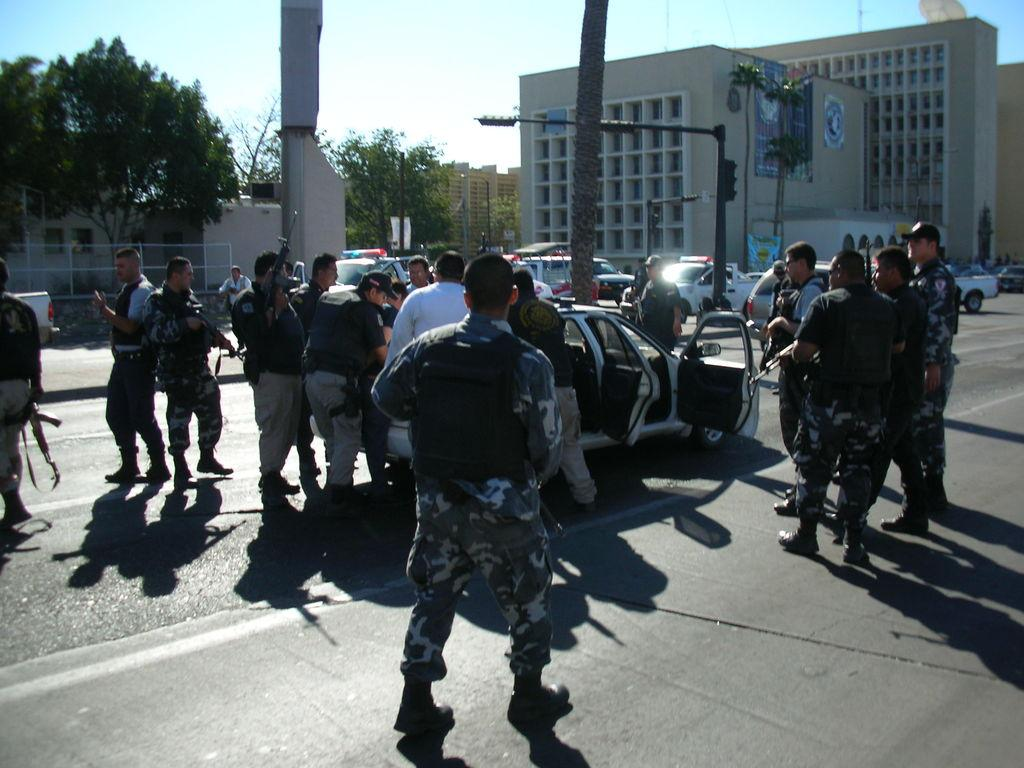What is happening in the image involving people and a car? There are people standing around a car in the image. What type of natural elements can be seen in the image? There are trees visible in the image. What man-made structures are present in the image? There are poles and buildings in the image. What color is the thread used to tie the car to the finger in the image? There is no thread or finger present in the image, and the car is not tied to anything. What time of day is depicted in the image? The provided facts do not give any information about the time of day, so it cannot be determined from the image. 